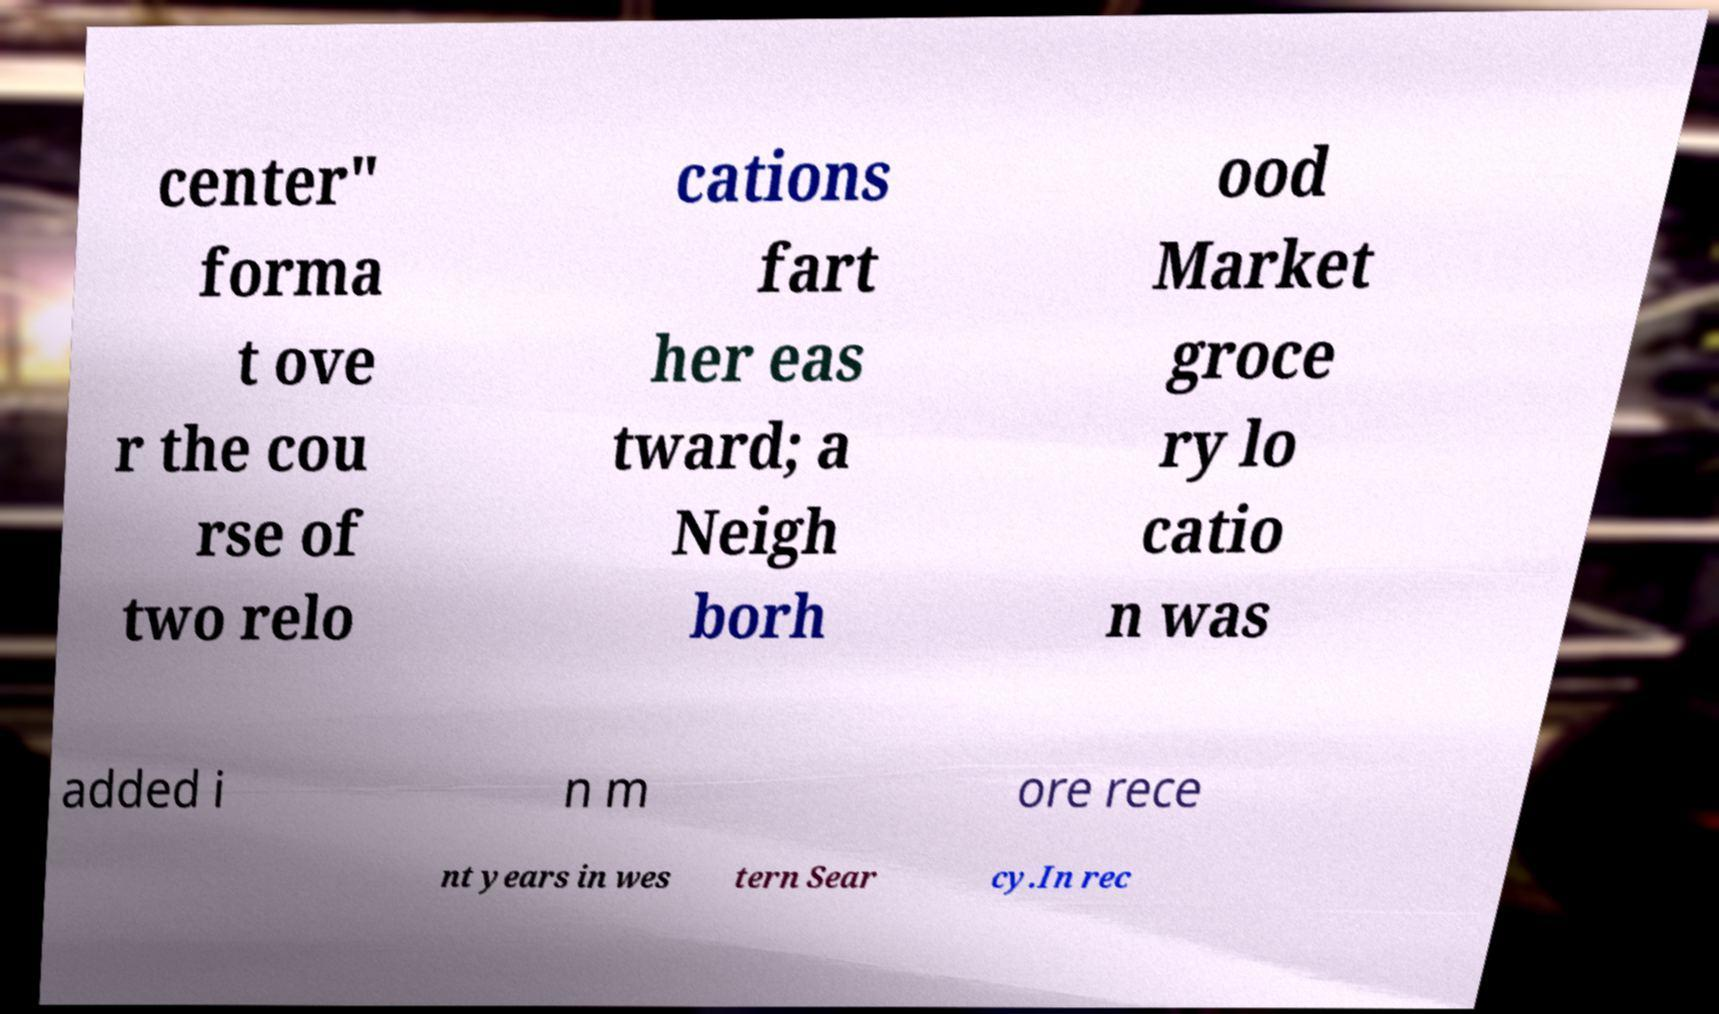Can you accurately transcribe the text from the provided image for me? center" forma t ove r the cou rse of two relo cations fart her eas tward; a Neigh borh ood Market groce ry lo catio n was added i n m ore rece nt years in wes tern Sear cy.In rec 